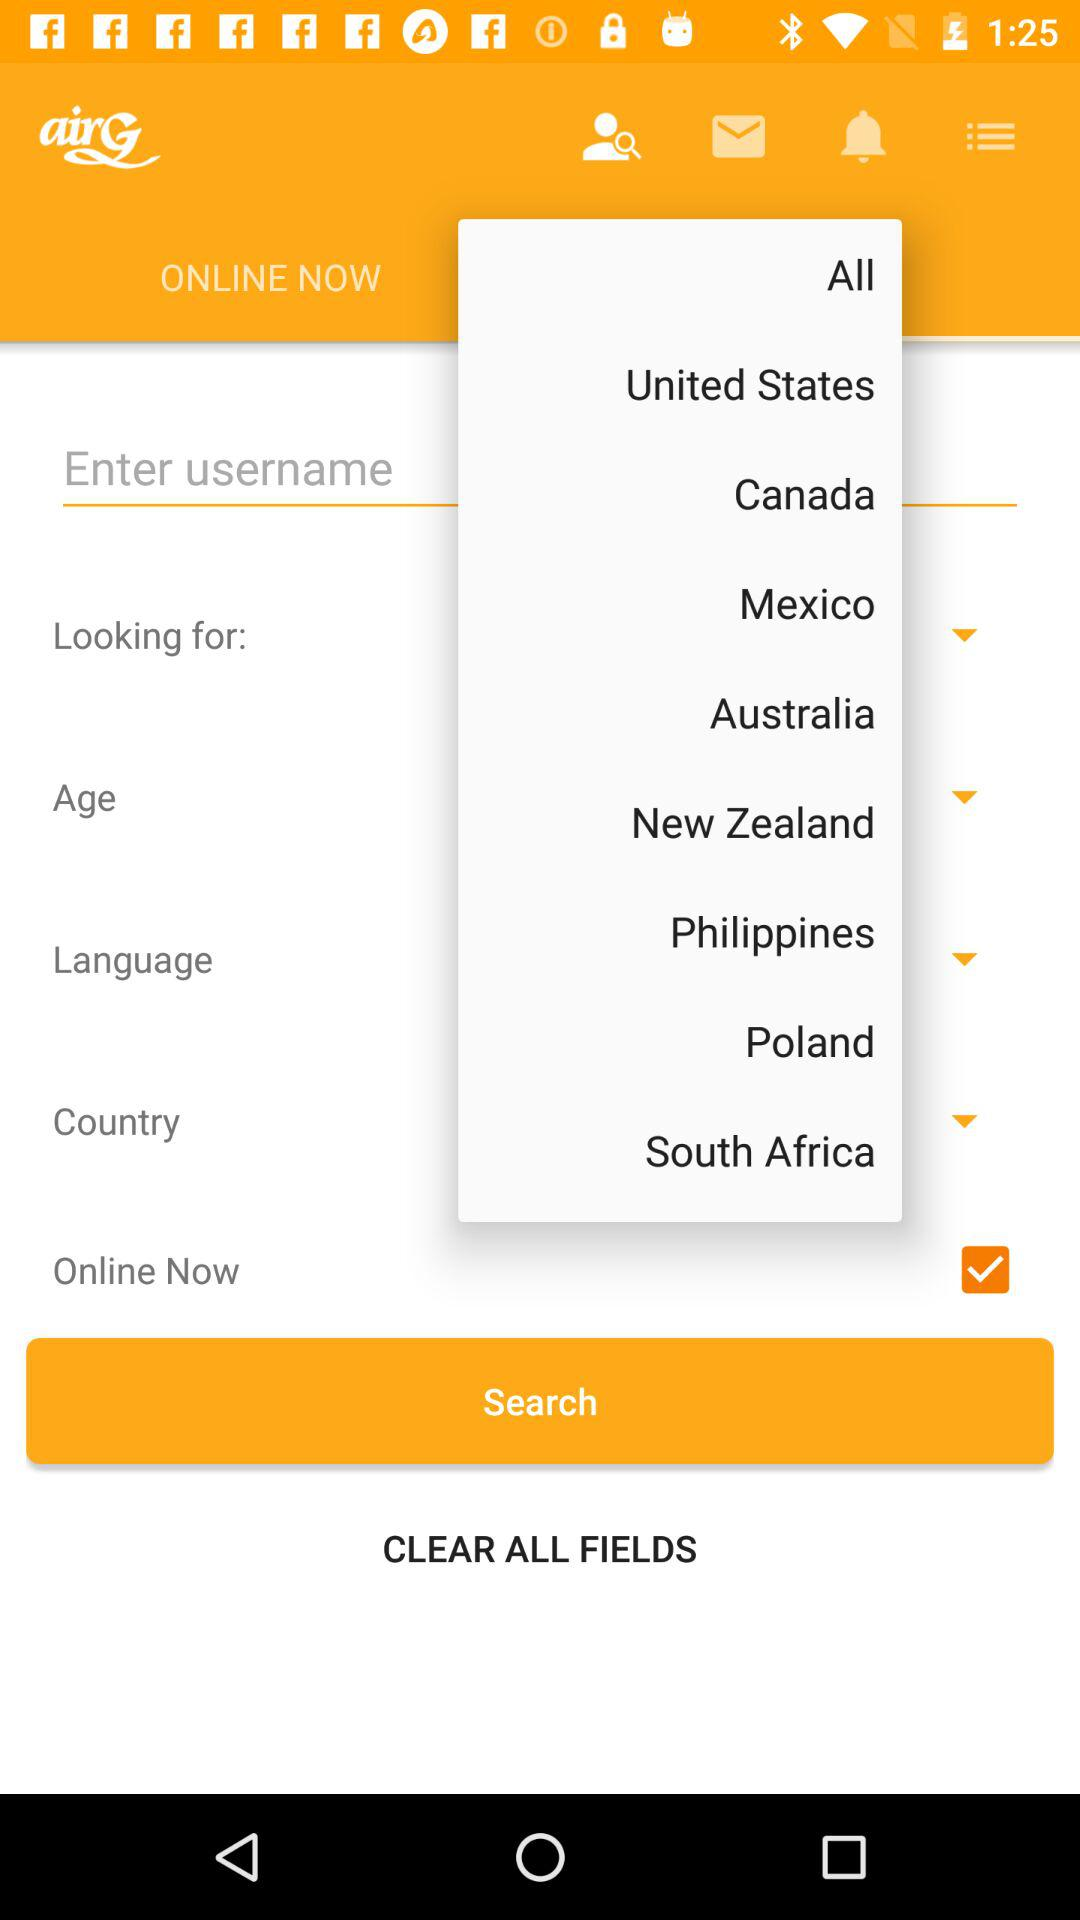What are the names of the available countries? The names of the available countries are the United States, Canada, Mexico, Australia, New Zealand, Philippines, Poland and South Africa. 